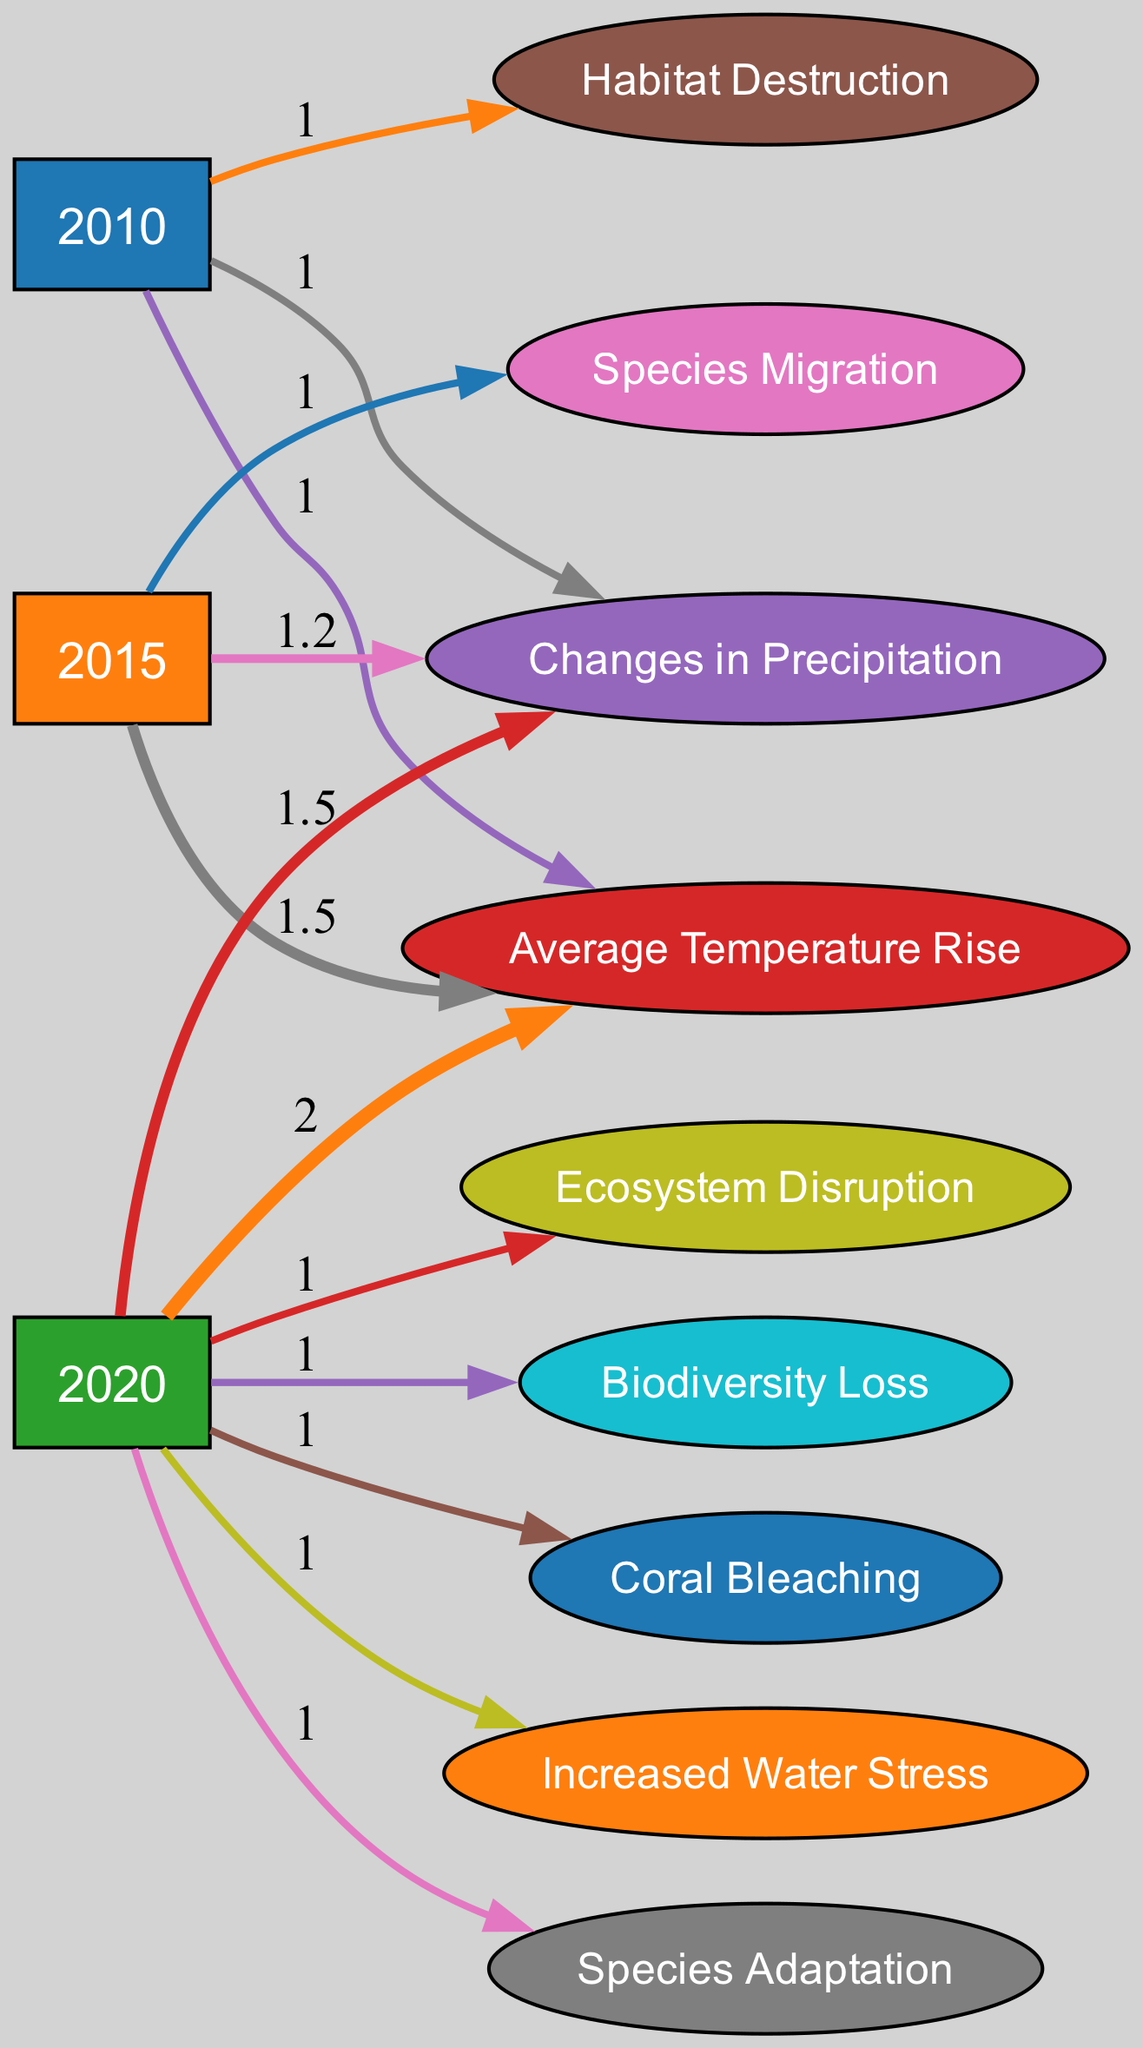What is the total value of species migration in 2015? The value for species migration in 2015 is directly taken from the links section, where it shows a flow from 2015 to species migration with a value of 1.
Answer: 1 What are the impacts resulting from the year 2020? The impacts from year 2020 include temperature rise, precipitation change, species adaptation, ecosystem disruption, biodiversity loss, coral bleaching, and increased water stress. The connections from 2020 to each of these nodes indicate that they are all affected.
Answer: Temperature rise, Precipitation change, Species adaptation, Ecosystem disruption, Biodiversity loss, Coral bleaching, Increased water stress How many nodes are there for the year 2010? There are three links that are directed from the year 2010 to its impact nodes: temperature rise, precipitation change, and habitat destruction. Thus, we count these nodes directly connected to 2010.
Answer: 3 What is the relationship between increased water stress and species adaptation? In the diagram, there is no direct flow or connection between increased water stress and species adaptation. Therefore, they do not directly influence each other in the context of the provided data.
Answer: None What was the change in average temperature from 2015 to 2020? From the links, we note that the value for average temperature rise in 2015 is 1.5 and in 2020 it is 2. So, the change can be calculated as 2 (2020) - 1.5 (2015) = 0.5.
Answer: 0.5 Which ecosystem impact had the highest value linked to the year 2020? Reviewing the links from the year 2020, each impact shows a flow value of 1, indicating they are all equal. Thus, all impacts stemming from 2020 hold the same value.
Answer: All equal at 1 What is the cumulative impact on biodiversity loss from 2010 to 2020? Examining the diagram, biodiversity loss appears only as a direct connection from 2020 with a flow value of 1. Therefore, since there is no additional connection from earlier years, the cumulative impact remains 1.
Answer: 1 How many total impacts are recorded for the year 2015? The year 2015 has three recorded impacts: temperature rise, precipitation change, and species migration. Counting these from the links section gives us the total.
Answer: 3 